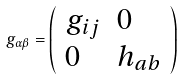<formula> <loc_0><loc_0><loc_500><loc_500>g _ { \alpha \beta } = \left ( \begin{array} { l l } { { g _ { i j } } } & { 0 } \\ { 0 } & { { h _ { a b } } } \end{array} \right )</formula> 